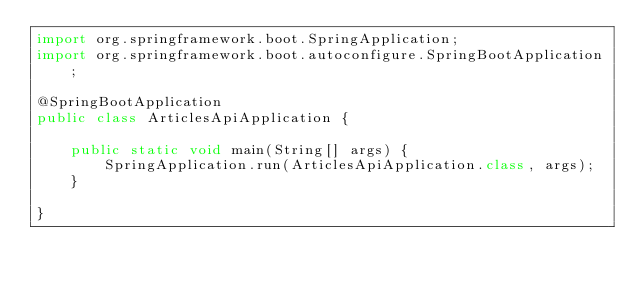Convert code to text. <code><loc_0><loc_0><loc_500><loc_500><_Java_>import org.springframework.boot.SpringApplication;
import org.springframework.boot.autoconfigure.SpringBootApplication;

@SpringBootApplication
public class ArticlesApiApplication {

	public static void main(String[] args) {
		SpringApplication.run(ArticlesApiApplication.class, args);
	}

}
</code> 